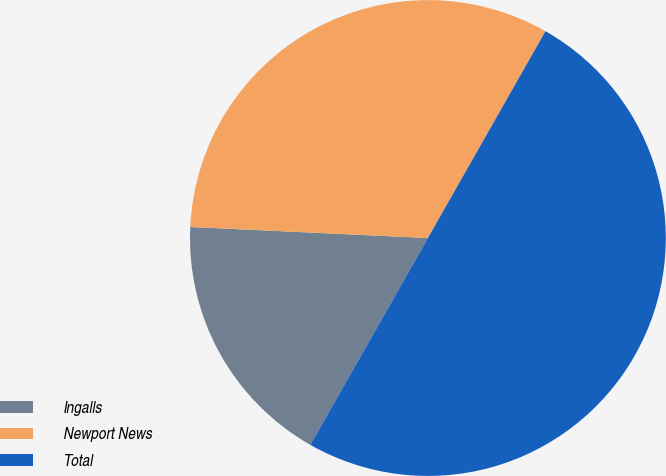Convert chart. <chart><loc_0><loc_0><loc_500><loc_500><pie_chart><fcel>Ingalls<fcel>Newport News<fcel>Total<nl><fcel>17.51%<fcel>32.49%<fcel>50.0%<nl></chart> 